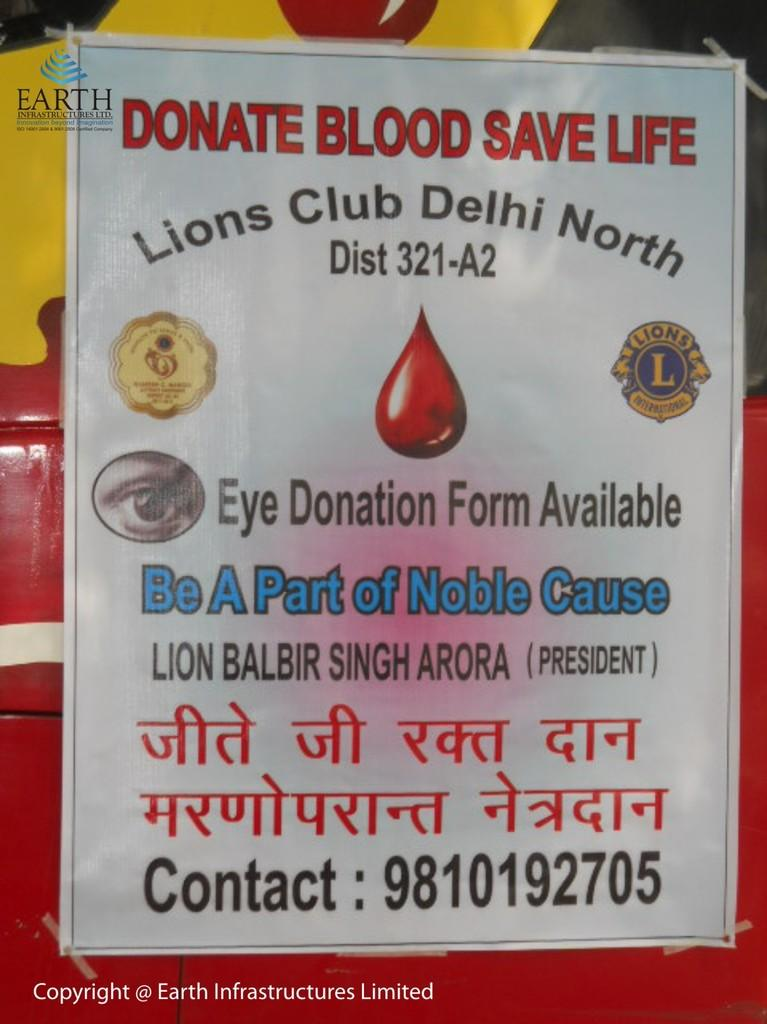What is the main subject of the poster in the image? There is a poster in the image, and the main subject is a blood drop image at the center of the poster. Are there any other images or symbols on the poster? Yes, there is an image of an eye on the left side of the poster. How many logos are present on the poster? There are 2 logos on the poster. What can be found on the poster besides images and logos? Text is written on the poster. What colors are used for the background of the poster? The background of the poster is red and yellow. Where is the boot located in the image? There is no boot present in the image. What type of rifle is depicted on the poster? There is no rifle present in the image. 